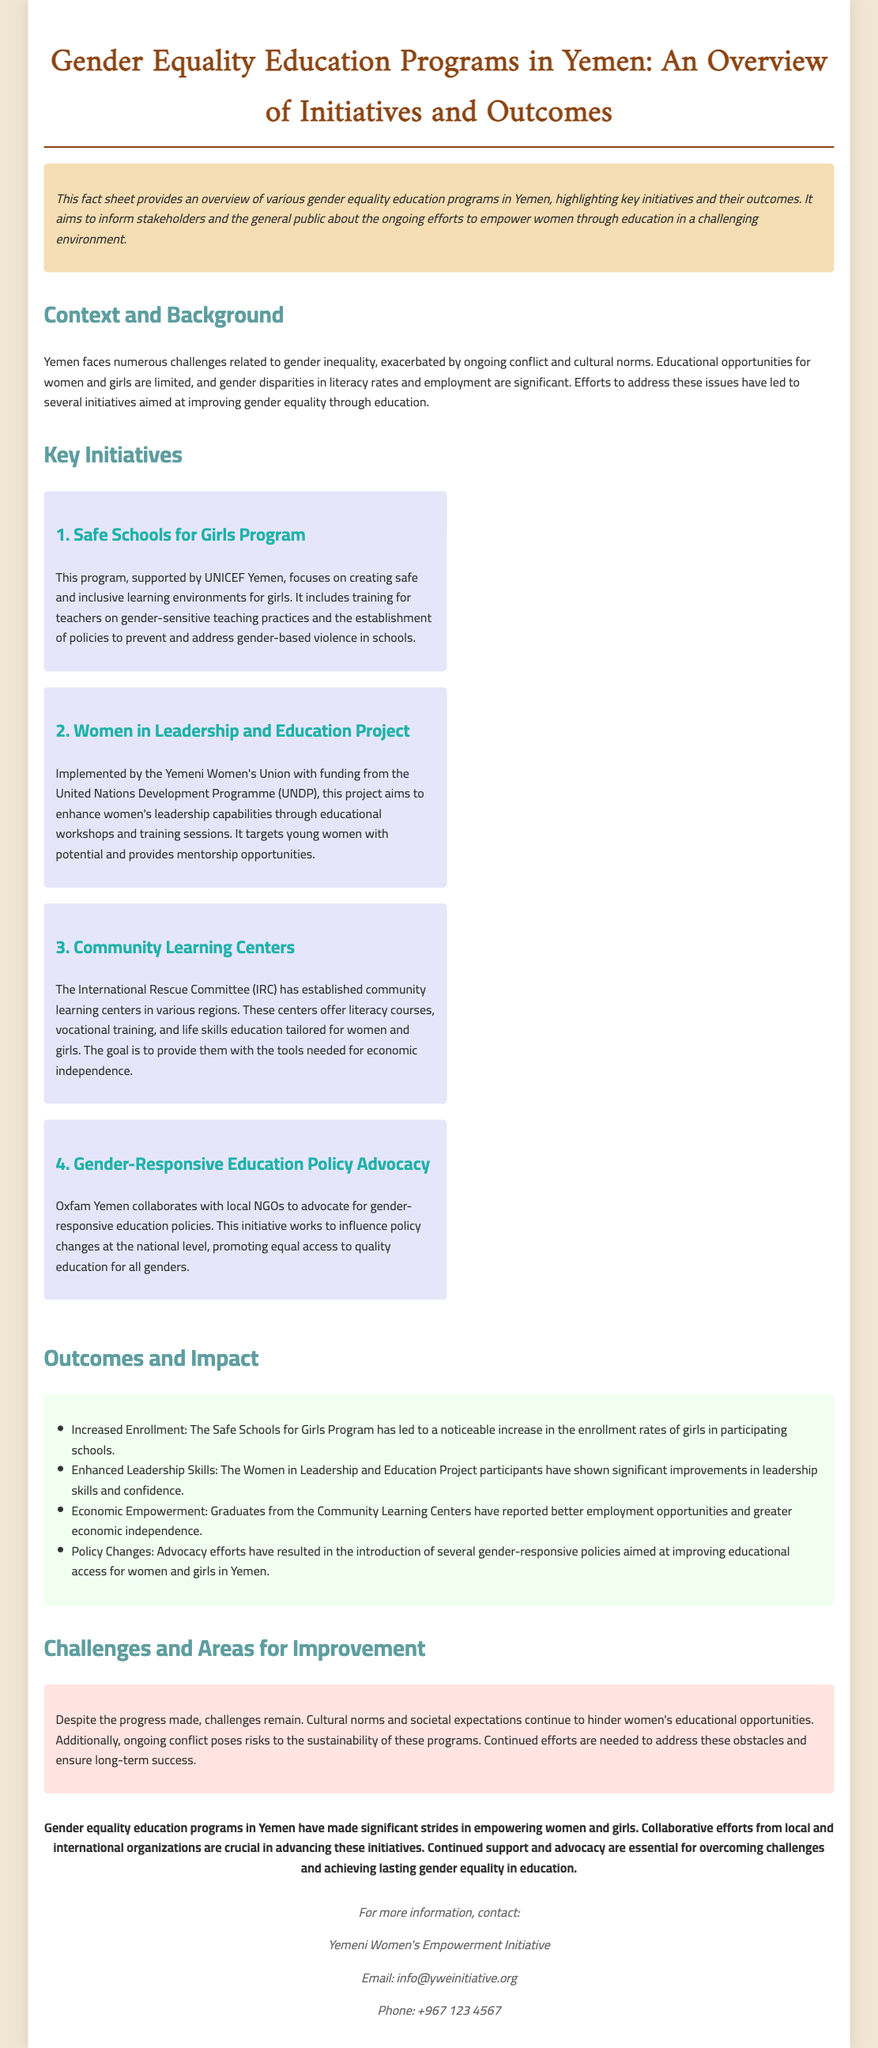What is the title of the document? The title is stated at the top of the document, which summarizes its main focus on education programs related to gender equality in Yemen.
Answer: Gender Equality Education Programs in Yemen: An Overview of Initiatives and Outcomes Who supports the Safe Schools for Girls Program? The document mentions that this program is supported by UNICEF Yemen, providing crucial backing for its initiatives.
Answer: UNICEF Yemen Which organization implements the Women in Leadership and Education Project? The document specifies that the Yemeni Women's Union is responsible for implementing this project, highlighting its focus on women's empowerment.
Answer: Yemeni Women's Union What has been reported by graduates of the Community Learning Centers? The document indicates that graduates report better employment opportunities and greater economic independence, showcasing the positive outcomes of the program.
Answer: Better employment opportunities and greater economic independence What is one of the outcomes of the advocacy efforts by Oxfam Yemen? The document states that advocacy efforts resulted in the introduction of gender-responsive policies, demonstrating their impact on educational access for women and girls.
Answer: Introduction of several gender-responsive policies What is a major challenge faced by the gender equality education programs? The document highlights ongoing conflict as a significant obstacle to the sustainability of these educational programs.
Answer: Ongoing conflict What does the conclusion emphasize as crucial for the success of these initiatives? The conclusion points out the importance of collaborative efforts from local and international organizations for advancing the gender equality education programs.
Answer: Collaborative efforts from local and international organizations What is the email contact provided for more information? The document provides a specific email address for inquiries related to the Yemeni Women's Empowerment Initiative.
Answer: info@yweinitiative.org 